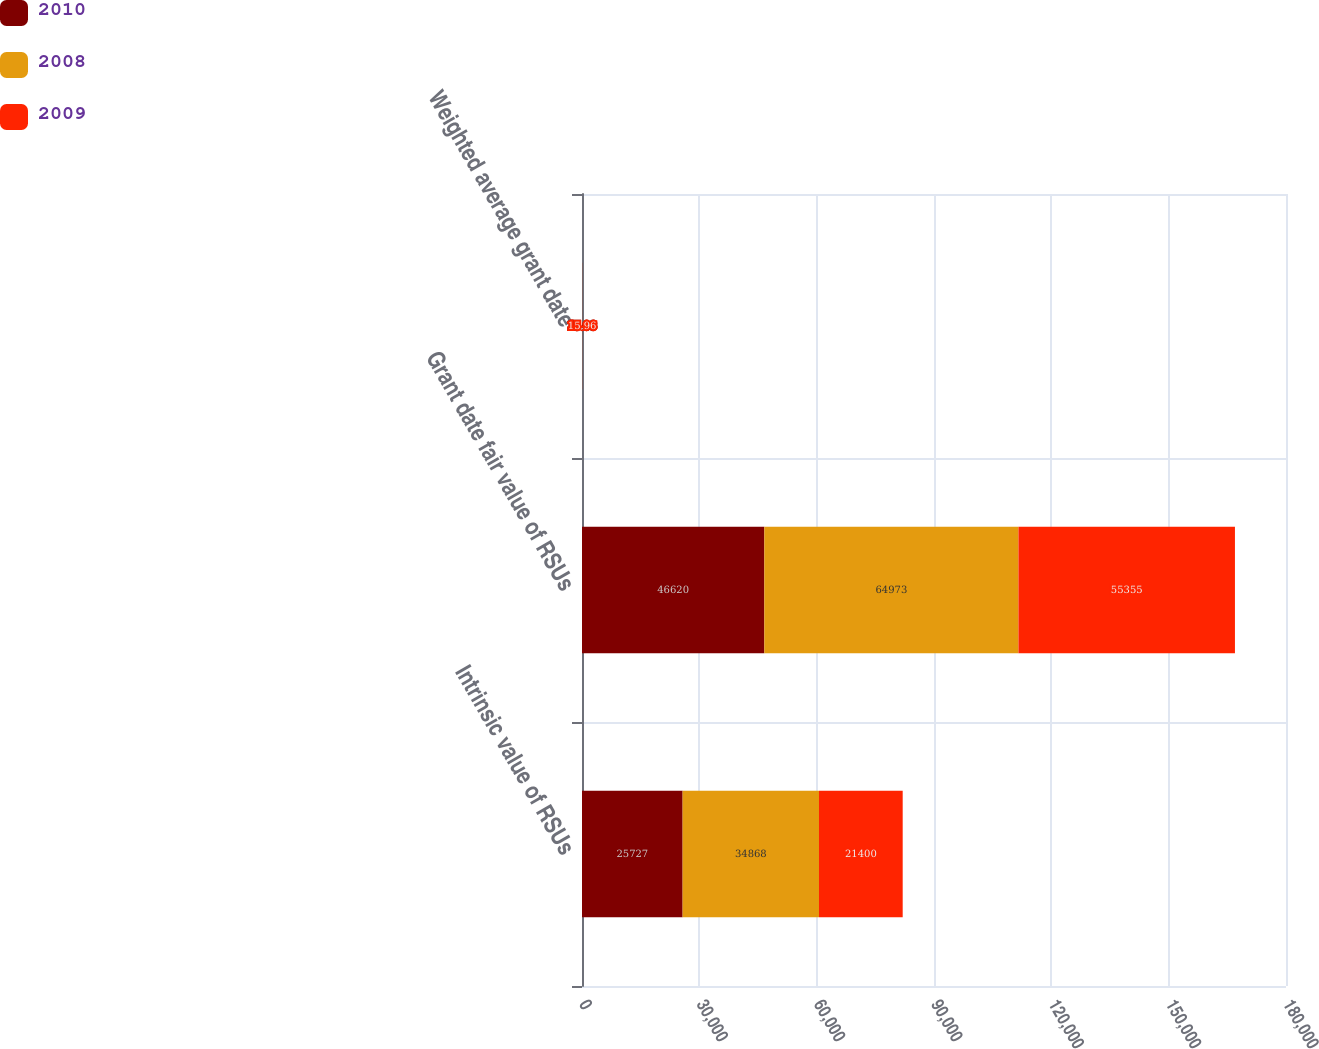Convert chart to OTSL. <chart><loc_0><loc_0><loc_500><loc_500><stacked_bar_chart><ecel><fcel>Intrinsic value of RSUs<fcel>Grant date fair value of RSUs<fcel>Weighted average grant date<nl><fcel>2010<fcel>25727<fcel>46620<fcel>15.08<nl><fcel>2008<fcel>34868<fcel>64973<fcel>10.36<nl><fcel>2009<fcel>21400<fcel>55355<fcel>15.96<nl></chart> 